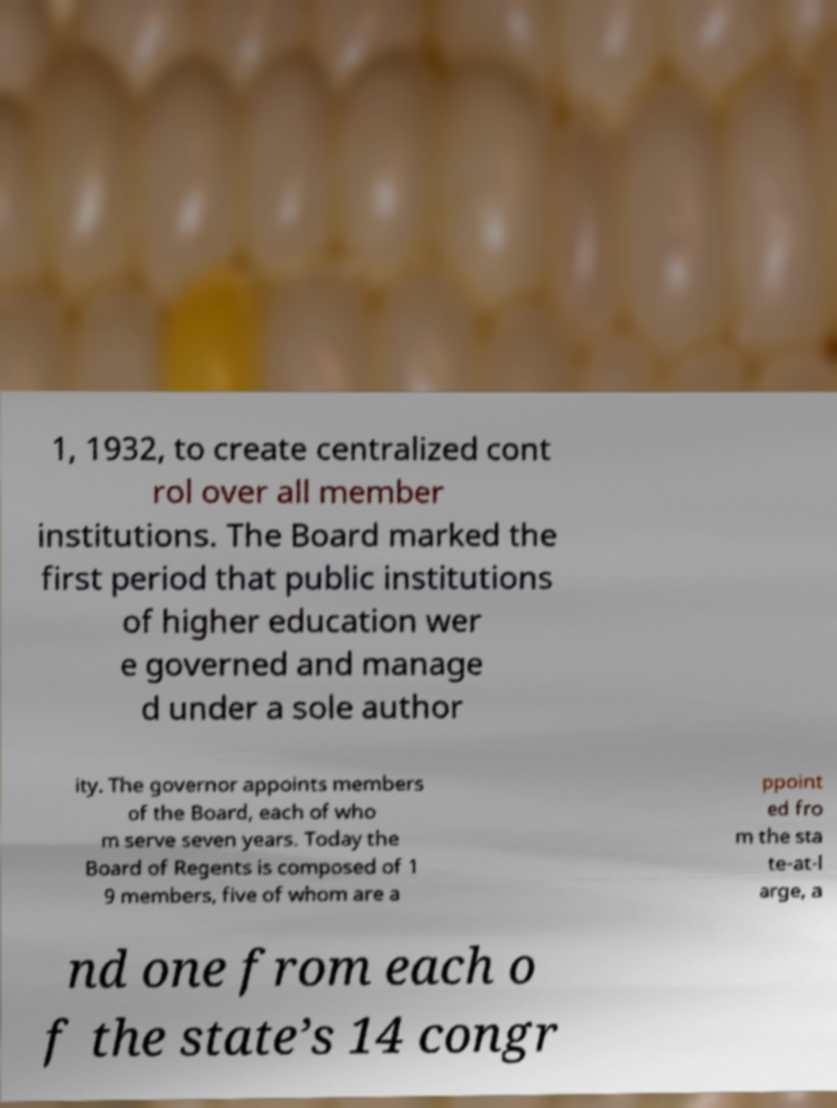Can you read and provide the text displayed in the image?This photo seems to have some interesting text. Can you extract and type it out for me? 1, 1932, to create centralized cont rol over all member institutions. The Board marked the first period that public institutions of higher education wer e governed and manage d under a sole author ity. The governor appoints members of the Board, each of who m serve seven years. Today the Board of Regents is composed of 1 9 members, five of whom are a ppoint ed fro m the sta te-at-l arge, a nd one from each o f the state’s 14 congr 